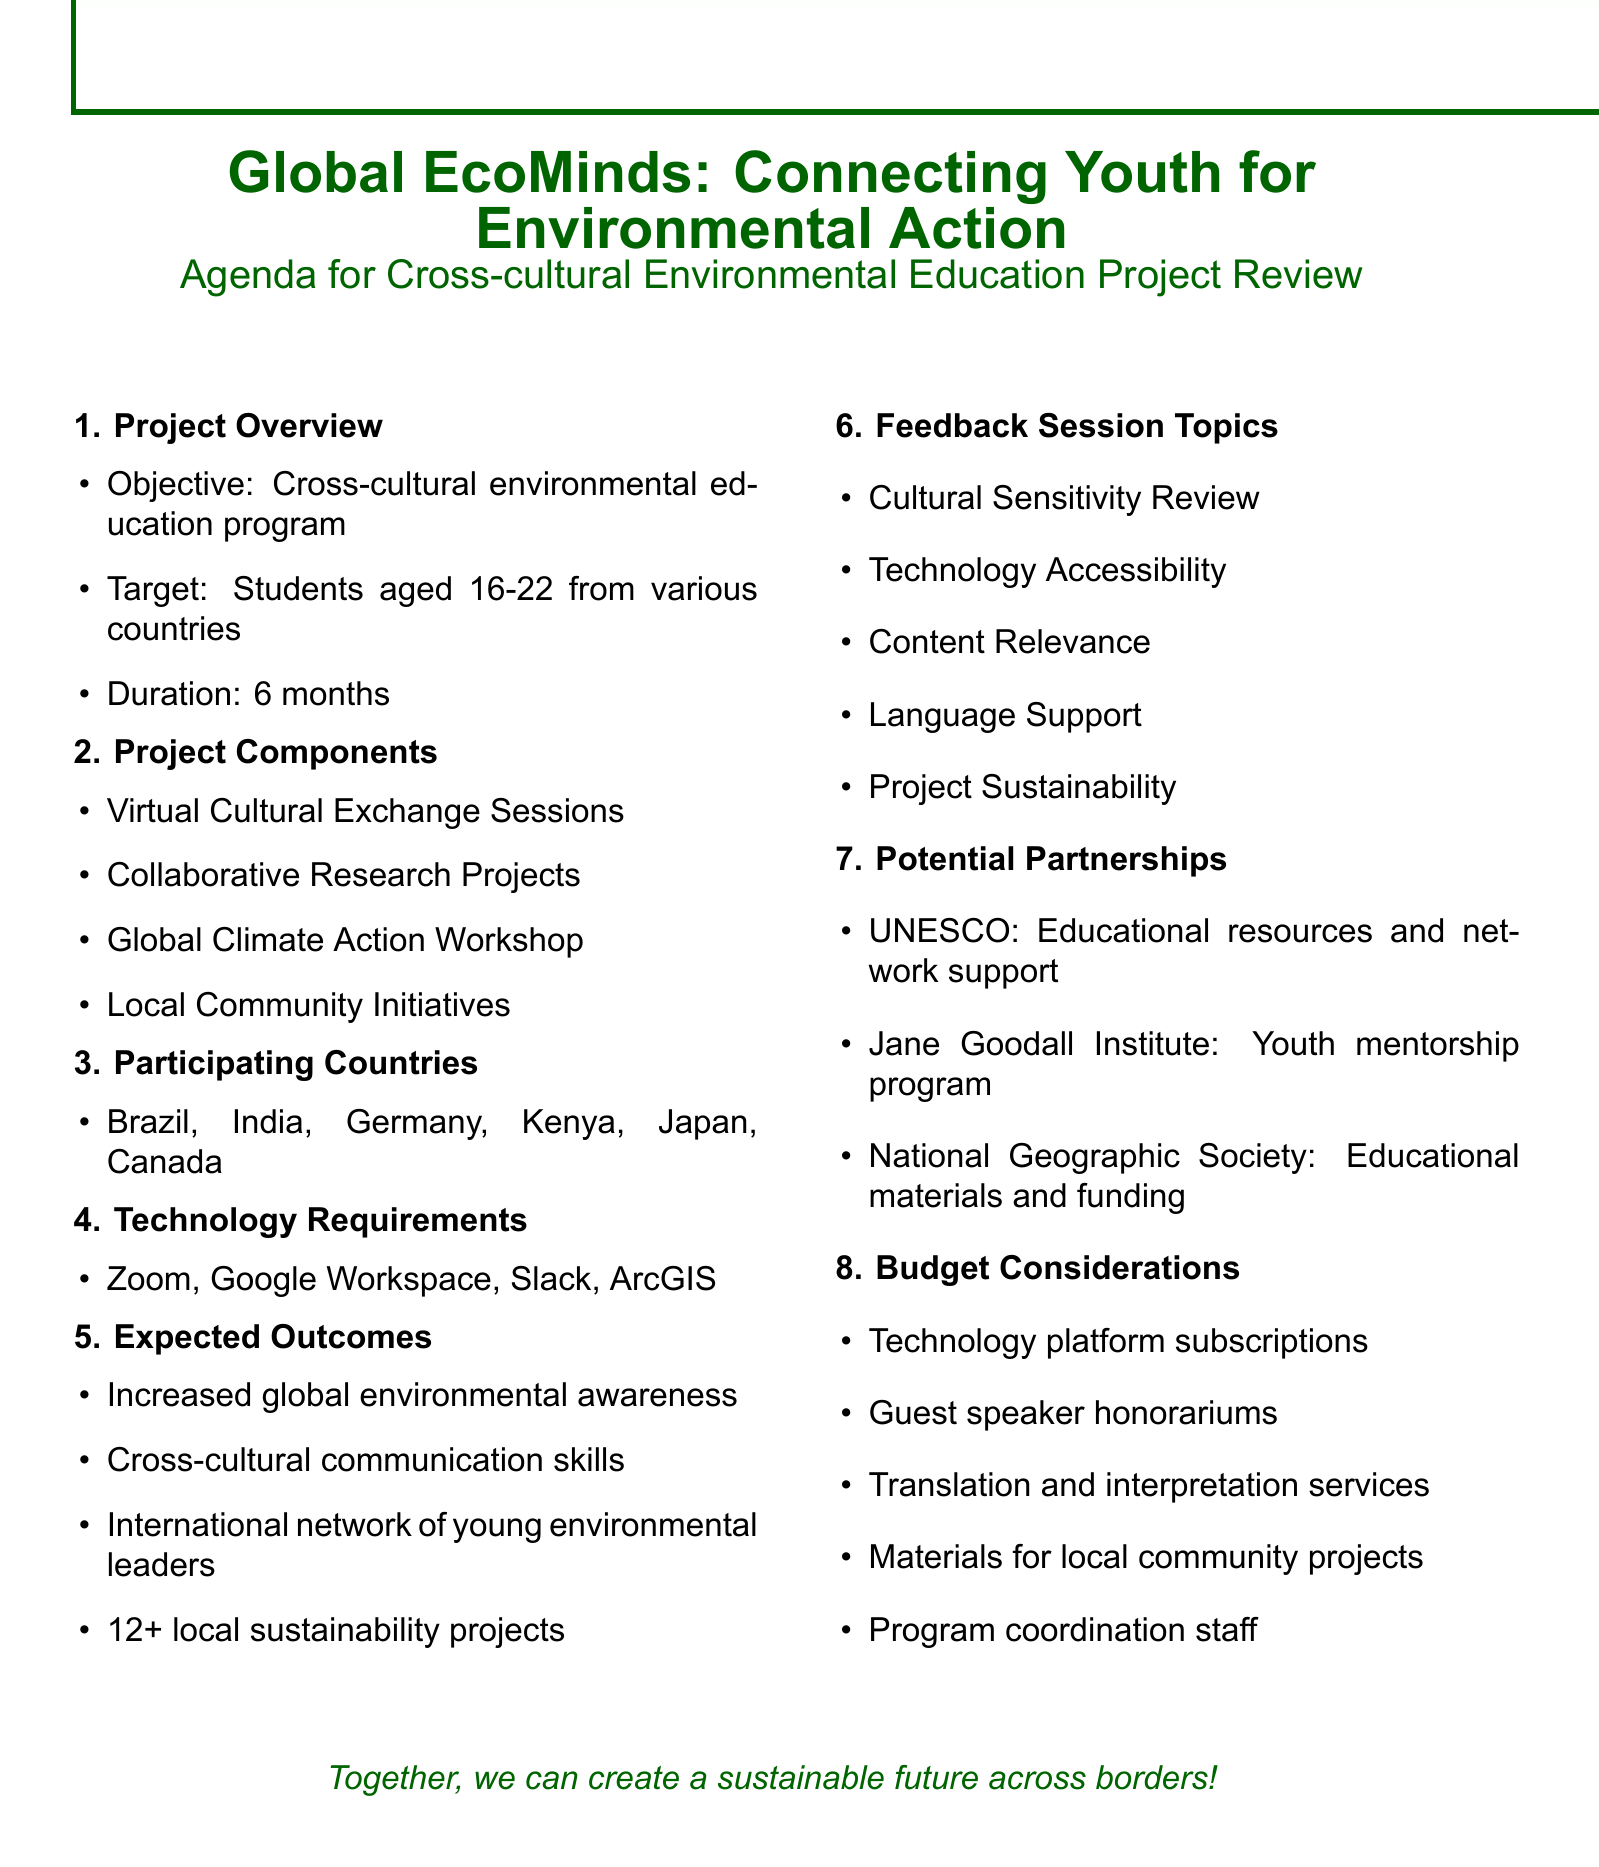What is the title of the project? The title is listed prominently at the beginning of the document.
Answer: Global EcoMinds: Connecting Youth for Environmental Action How long is the project duration? The duration is specified in the project overview section.
Answer: 6 months What are the first two participating countries? The participating countries are listed in a single line; the first two are asked for specifically.
Answer: Brazil, India What is one of the expected outcomes? Expected outcomes are specified and can be retrieved from that section.
Answer: Increased global environmental awareness among participants Which platform is used for team communication? The technology requirements section explicitly lists the platforms used.
Answer: Slack What is discussed under Technology Accessibility? This topic is one of the feedback session topics and details potential issues.
Answer: Potential barriers to technology access and propose solutions for equitable participation What services will be reviewed for facilitating communication? This information is found in the feedback session topics section.
Answer: Translation and interpretation services Who can provide educational resources and network support? This information is found in the potential partnerships section.
Answer: UNESCO 